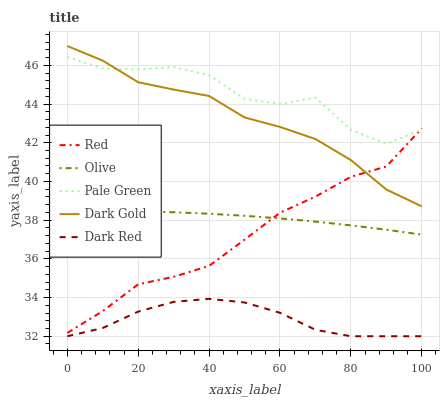Does Dark Red have the minimum area under the curve?
Answer yes or no. Yes. Does Pale Green have the maximum area under the curve?
Answer yes or no. Yes. Does Pale Green have the minimum area under the curve?
Answer yes or no. No. Does Dark Red have the maximum area under the curve?
Answer yes or no. No. Is Olive the smoothest?
Answer yes or no. Yes. Is Pale Green the roughest?
Answer yes or no. Yes. Is Dark Red the smoothest?
Answer yes or no. No. Is Dark Red the roughest?
Answer yes or no. No. Does Dark Red have the lowest value?
Answer yes or no. Yes. Does Pale Green have the lowest value?
Answer yes or no. No. Does Dark Gold have the highest value?
Answer yes or no. Yes. Does Pale Green have the highest value?
Answer yes or no. No. Is Olive less than Pale Green?
Answer yes or no. Yes. Is Pale Green greater than Dark Red?
Answer yes or no. Yes. Does Red intersect Olive?
Answer yes or no. Yes. Is Red less than Olive?
Answer yes or no. No. Is Red greater than Olive?
Answer yes or no. No. Does Olive intersect Pale Green?
Answer yes or no. No. 